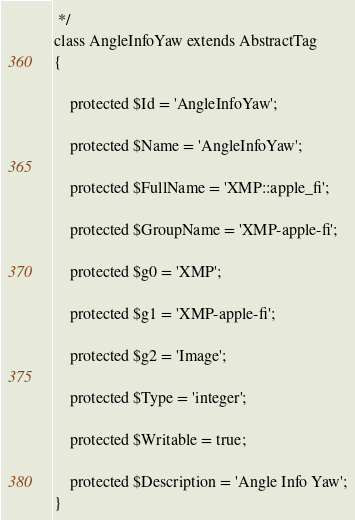Convert code to text. <code><loc_0><loc_0><loc_500><loc_500><_PHP_> */
class AngleInfoYaw extends AbstractTag
{

    protected $Id = 'AngleInfoYaw';

    protected $Name = 'AngleInfoYaw';

    protected $FullName = 'XMP::apple_fi';

    protected $GroupName = 'XMP-apple-fi';

    protected $g0 = 'XMP';

    protected $g1 = 'XMP-apple-fi';

    protected $g2 = 'Image';

    protected $Type = 'integer';

    protected $Writable = true;

    protected $Description = 'Angle Info Yaw';
}
</code> 